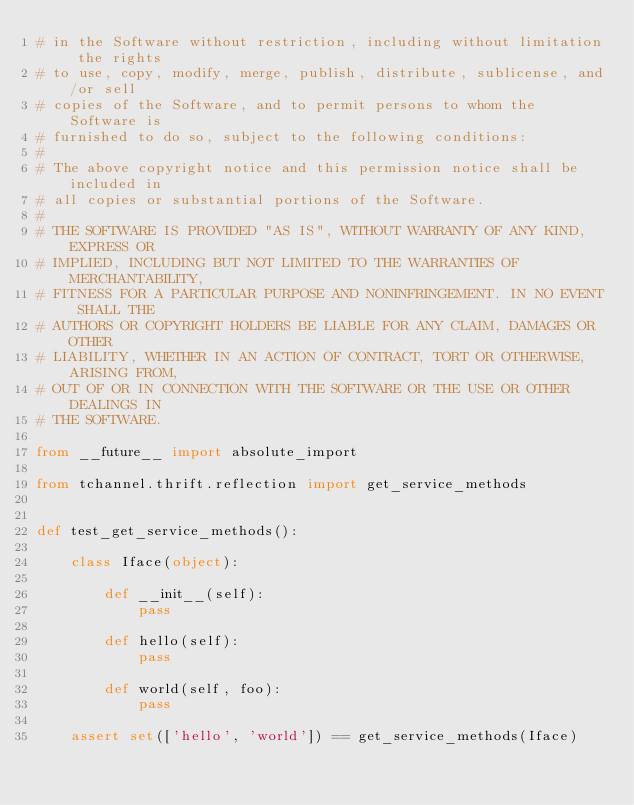<code> <loc_0><loc_0><loc_500><loc_500><_Python_># in the Software without restriction, including without limitation the rights
# to use, copy, modify, merge, publish, distribute, sublicense, and/or sell
# copies of the Software, and to permit persons to whom the Software is
# furnished to do so, subject to the following conditions:
#
# The above copyright notice and this permission notice shall be included in
# all copies or substantial portions of the Software.
#
# THE SOFTWARE IS PROVIDED "AS IS", WITHOUT WARRANTY OF ANY KIND, EXPRESS OR
# IMPLIED, INCLUDING BUT NOT LIMITED TO THE WARRANTIES OF MERCHANTABILITY,
# FITNESS FOR A PARTICULAR PURPOSE AND NONINFRINGEMENT. IN NO EVENT SHALL THE
# AUTHORS OR COPYRIGHT HOLDERS BE LIABLE FOR ANY CLAIM, DAMAGES OR OTHER
# LIABILITY, WHETHER IN AN ACTION OF CONTRACT, TORT OR OTHERWISE, ARISING FROM,
# OUT OF OR IN CONNECTION WITH THE SOFTWARE OR THE USE OR OTHER DEALINGS IN
# THE SOFTWARE.

from __future__ import absolute_import

from tchannel.thrift.reflection import get_service_methods


def test_get_service_methods():

    class Iface(object):

        def __init__(self):
            pass

        def hello(self):
            pass

        def world(self, foo):
            pass

    assert set(['hello', 'world']) == get_service_methods(Iface)
</code> 